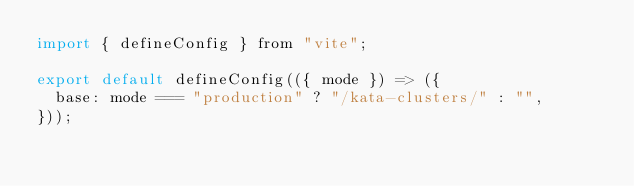<code> <loc_0><loc_0><loc_500><loc_500><_JavaScript_>import { defineConfig } from "vite";

export default defineConfig(({ mode }) => ({
  base: mode === "production" ? "/kata-clusters/" : "",
}));
</code> 